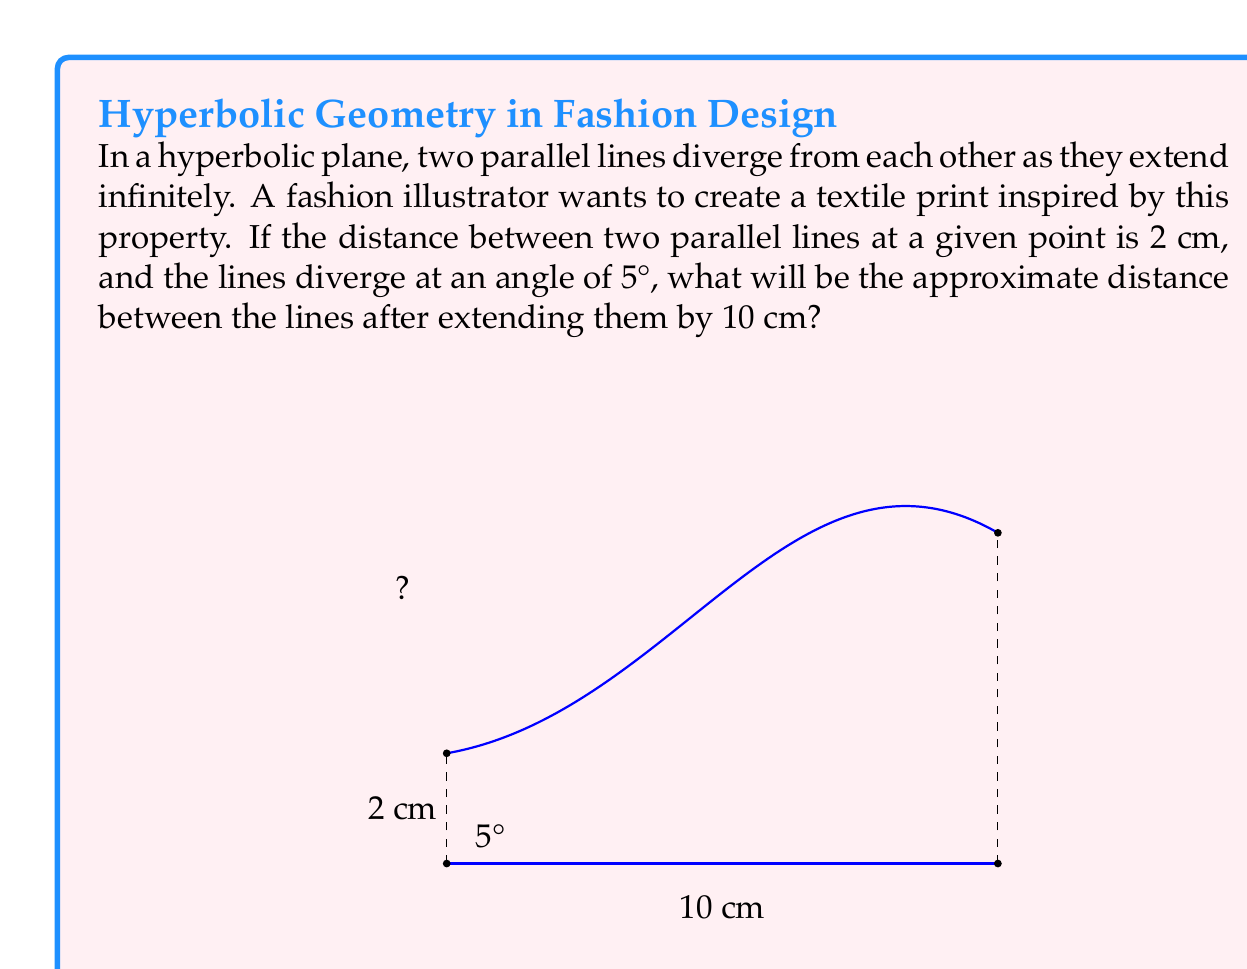What is the answer to this math problem? To solve this problem, we'll use concepts from hyperbolic geometry and some trigonometry. Let's break it down step-by-step:

1) In Euclidean geometry, parallel lines maintain a constant distance. However, in hyperbolic geometry, parallel lines diverge.

2) We can approximate the divergence over a short distance using a right triangle model:

   - The base of the triangle is the extension length: 10 cm
   - The angle of divergence is given: 5° or $\frac{5\pi}{180}$ radians
   - We need to find the additional distance between the lines

3) Let's call the additional distance $x$. We can use the tangent function:

   $$\tan(5°) = \frac{x}{10}$$

4) Solving for $x$:

   $$x = 10 \tan(5°)$$

5) Using a calculator or trigonometric tables:

   $$x \approx 10 \cdot 0.0875 = 0.875 \text{ cm}$$

6) The original distance between the lines was 2 cm. So the new distance will be:

   $$2 \text{ cm} + 0.875 \text{ cm} = 2.875 \text{ cm}$$

7) Rounding to the nearest tenth:

   $$2.875 \text{ cm} \approx 2.9 \text{ cm}$$

This approximation assumes a constant rate of divergence, which is not strictly true in hyperbolic geometry. However, for small distances and angles, it provides a reasonable estimate.
Answer: 2.9 cm 